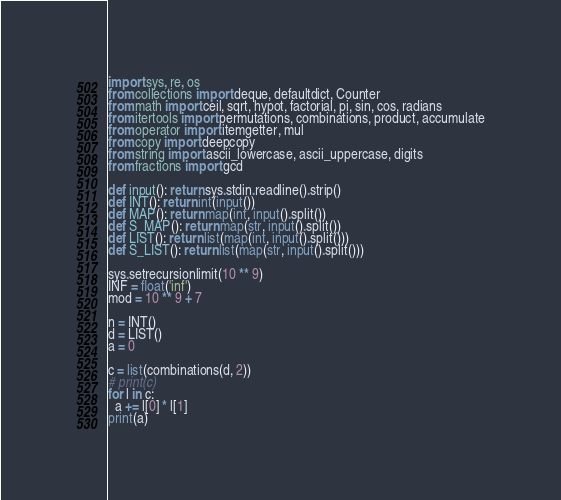Convert code to text. <code><loc_0><loc_0><loc_500><loc_500><_Python_>import sys, re, os
from collections import deque, defaultdict, Counter
from math import ceil, sqrt, hypot, factorial, pi, sin, cos, radians
from itertools import permutations, combinations, product, accumulate
from operator import itemgetter, mul
from copy import deepcopy
from string import ascii_lowercase, ascii_uppercase, digits
from fractions import gcd
 
def input(): return sys.stdin.readline().strip()
def INT(): return int(input())
def MAP(): return map(int, input().split())
def S_MAP(): return map(str, input().split())
def LIST(): return list(map(int, input().split()))
def S_LIST(): return list(map(str, input().split()))
 
sys.setrecursionlimit(10 ** 9)
INF = float('inf')
mod = 10 ** 9 + 7

n = INT()
d = LIST()
a = 0

c = list(combinations(d, 2))
# print(c)
for l in c:
  a += l[0] * l[1]
print(a)</code> 